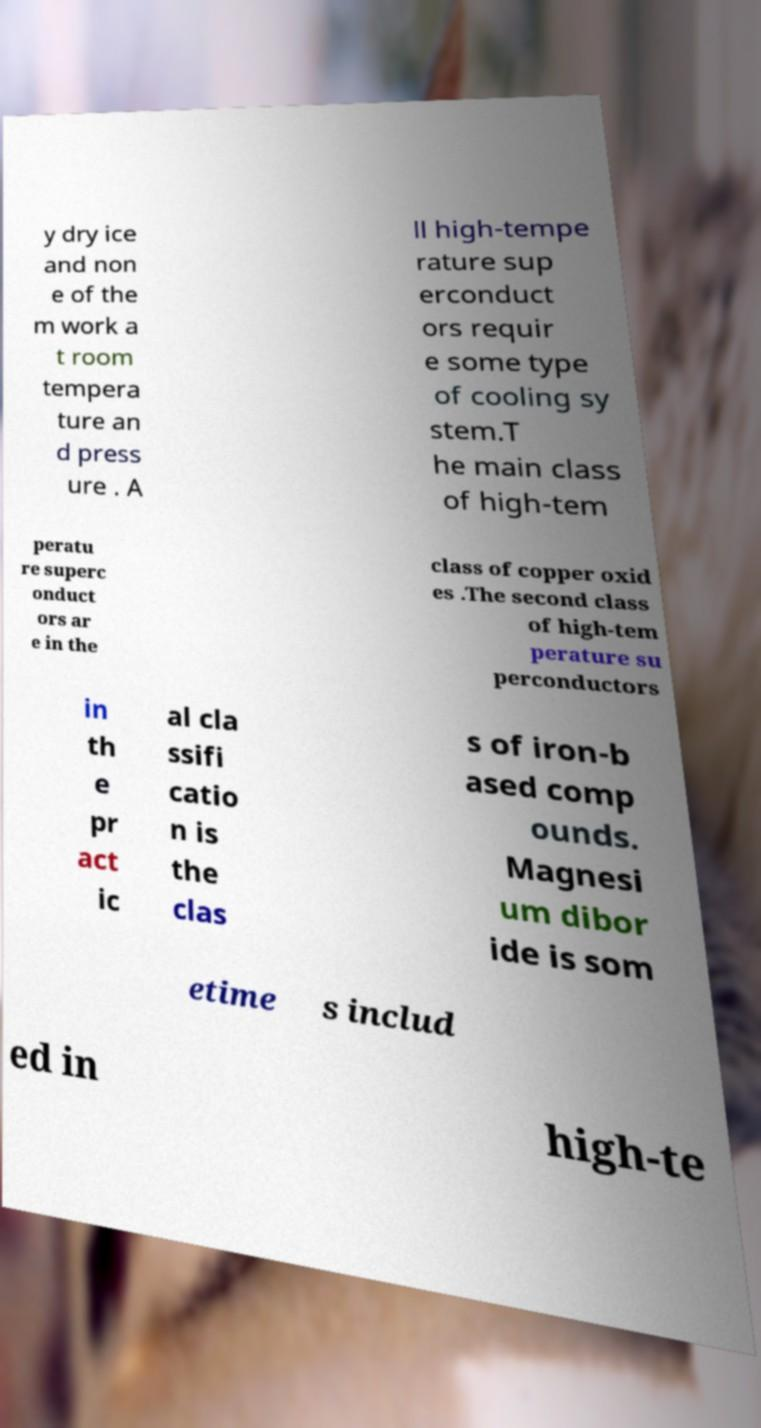Could you extract and type out the text from this image? y dry ice and non e of the m work a t room tempera ture an d press ure . A ll high-tempe rature sup erconduct ors requir e some type of cooling sy stem.T he main class of high-tem peratu re superc onduct ors ar e in the class of copper oxid es .The second class of high-tem perature su perconductors in th e pr act ic al cla ssifi catio n is the clas s of iron-b ased comp ounds. Magnesi um dibor ide is som etime s includ ed in high-te 